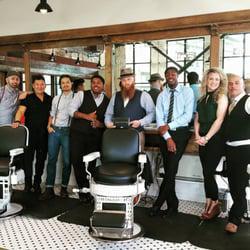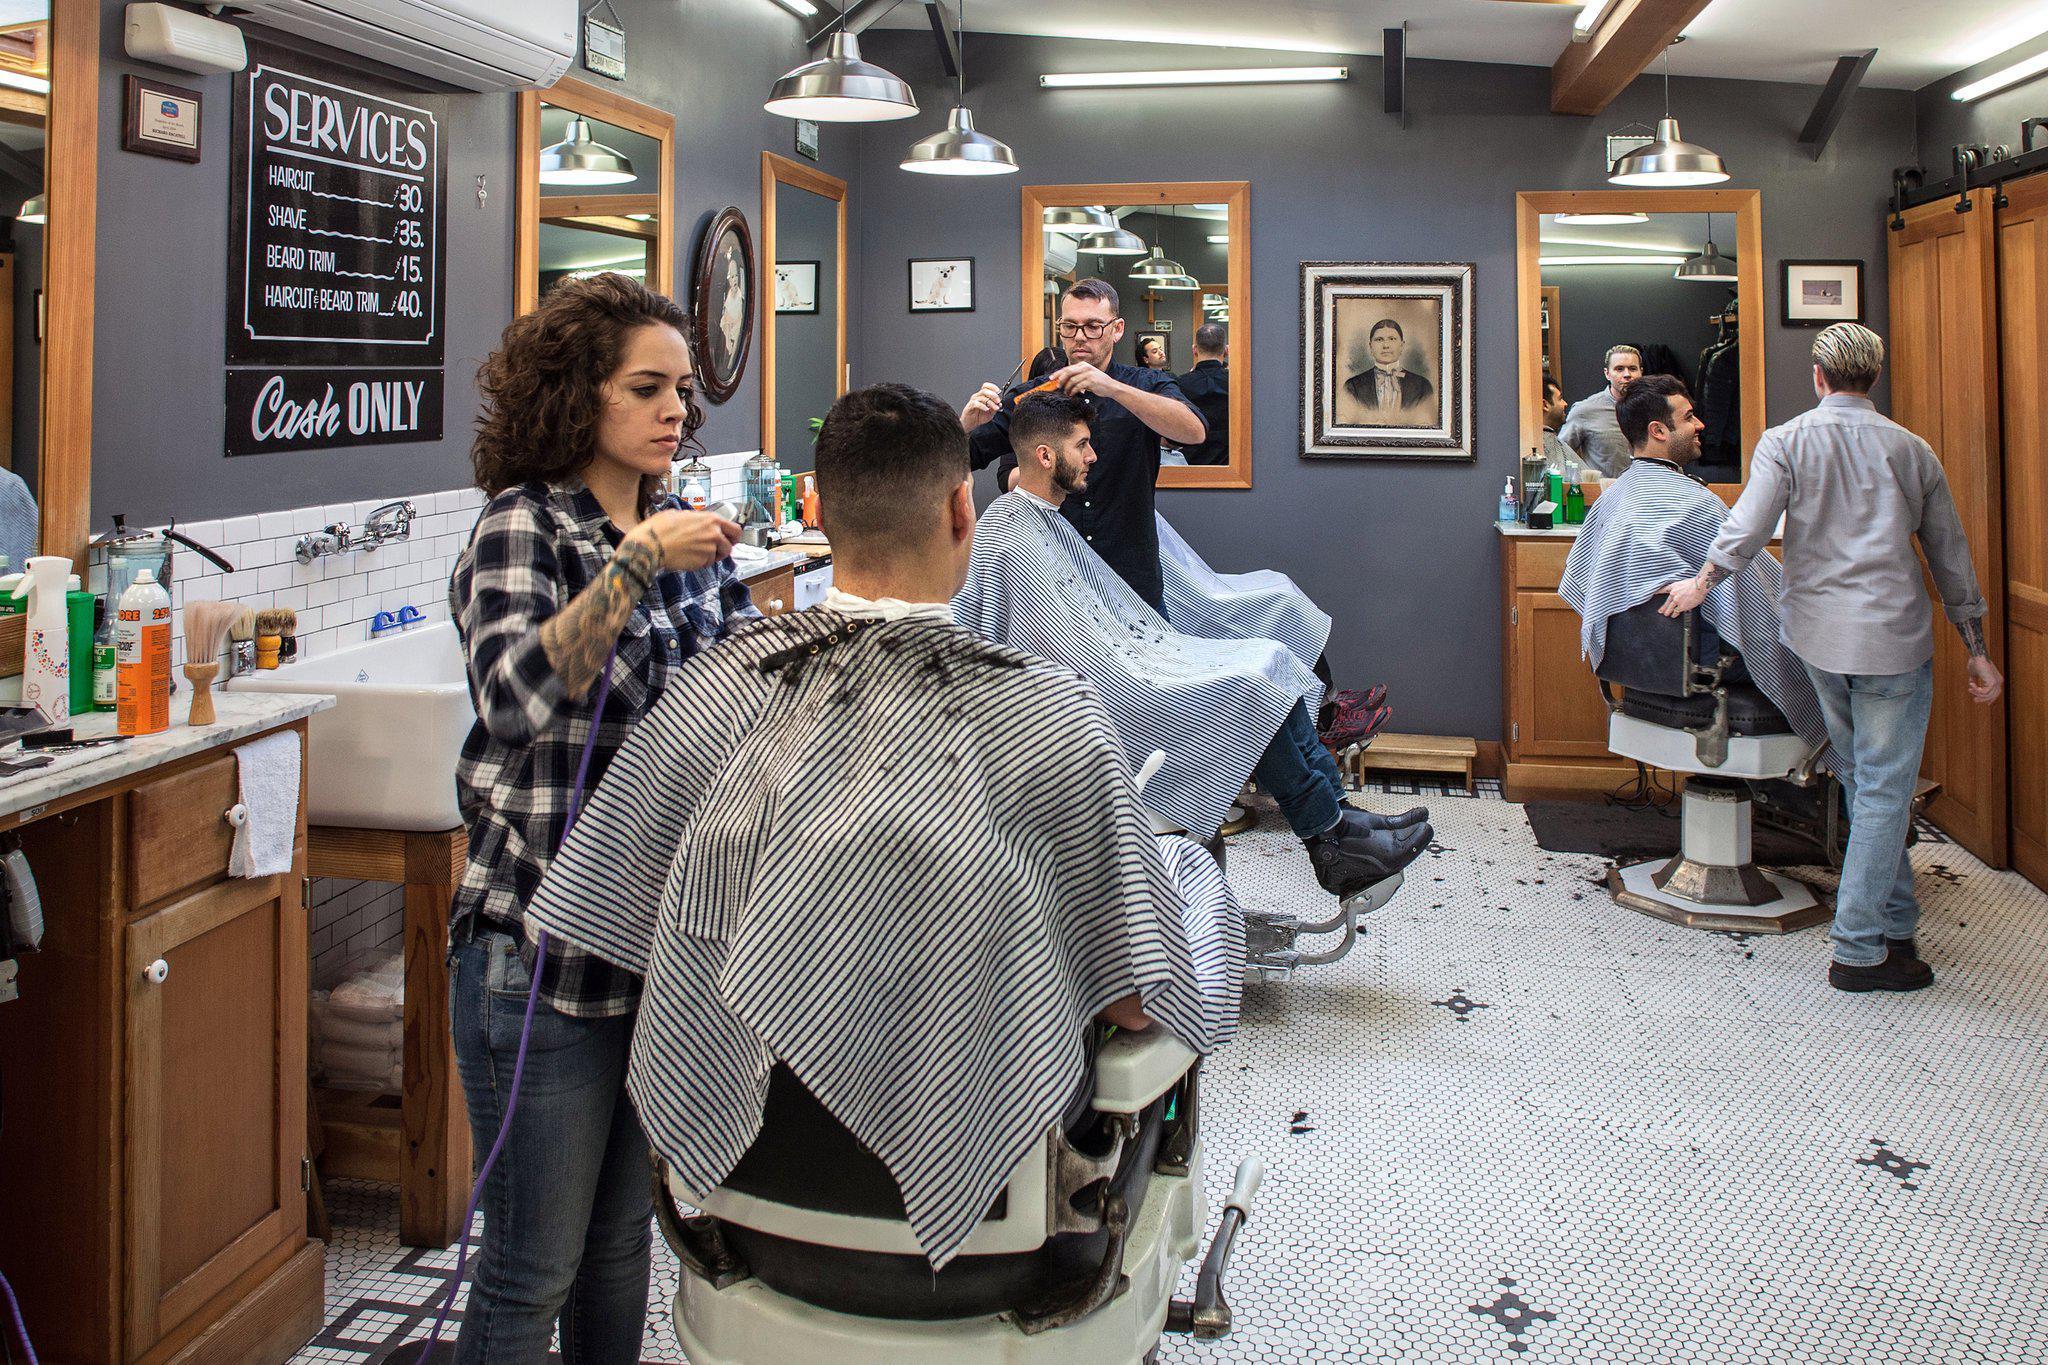The first image is the image on the left, the second image is the image on the right. For the images shown, is this caption "People are getting their haircut in exactly one image." true? Answer yes or no. Yes. The first image is the image on the left, the second image is the image on the right. Considering the images on both sides, is "Nobody is getting a haircut in the left image, but someone is in the right image." valid? Answer yes or no. Yes. 